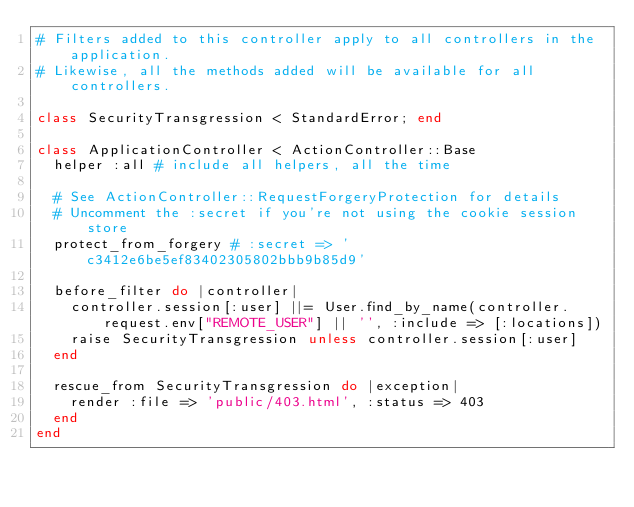<code> <loc_0><loc_0><loc_500><loc_500><_Ruby_># Filters added to this controller apply to all controllers in the application.
# Likewise, all the methods added will be available for all controllers.

class SecurityTransgression < StandardError; end

class ApplicationController < ActionController::Base
  helper :all # include all helpers, all the time

  # See ActionController::RequestForgeryProtection for details
  # Uncomment the :secret if you're not using the cookie session store
  protect_from_forgery # :secret => 'c3412e6be5ef83402305802bbb9b85d9'

  before_filter do |controller|
    controller.session[:user] ||= User.find_by_name(controller.request.env["REMOTE_USER"] || '', :include => [:locations])
    raise SecurityTransgression unless controller.session[:user]
  end
  
  rescue_from SecurityTransgression do |exception|
    render :file => 'public/403.html', :status => 403
  end
end
</code> 